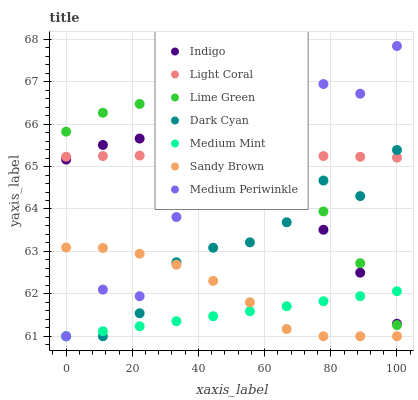Does Medium Mint have the minimum area under the curve?
Answer yes or no. Yes. Does Light Coral have the maximum area under the curve?
Answer yes or no. Yes. Does Indigo have the minimum area under the curve?
Answer yes or no. No. Does Indigo have the maximum area under the curve?
Answer yes or no. No. Is Medium Mint the smoothest?
Answer yes or no. Yes. Is Medium Periwinkle the roughest?
Answer yes or no. Yes. Is Indigo the smoothest?
Answer yes or no. No. Is Indigo the roughest?
Answer yes or no. No. Does Medium Mint have the lowest value?
Answer yes or no. Yes. Does Indigo have the lowest value?
Answer yes or no. No. Does Medium Periwinkle have the highest value?
Answer yes or no. Yes. Does Indigo have the highest value?
Answer yes or no. No. Is Sandy Brown less than Light Coral?
Answer yes or no. Yes. Is Light Coral greater than Medium Mint?
Answer yes or no. Yes. Does Lime Green intersect Dark Cyan?
Answer yes or no. Yes. Is Lime Green less than Dark Cyan?
Answer yes or no. No. Is Lime Green greater than Dark Cyan?
Answer yes or no. No. Does Sandy Brown intersect Light Coral?
Answer yes or no. No. 